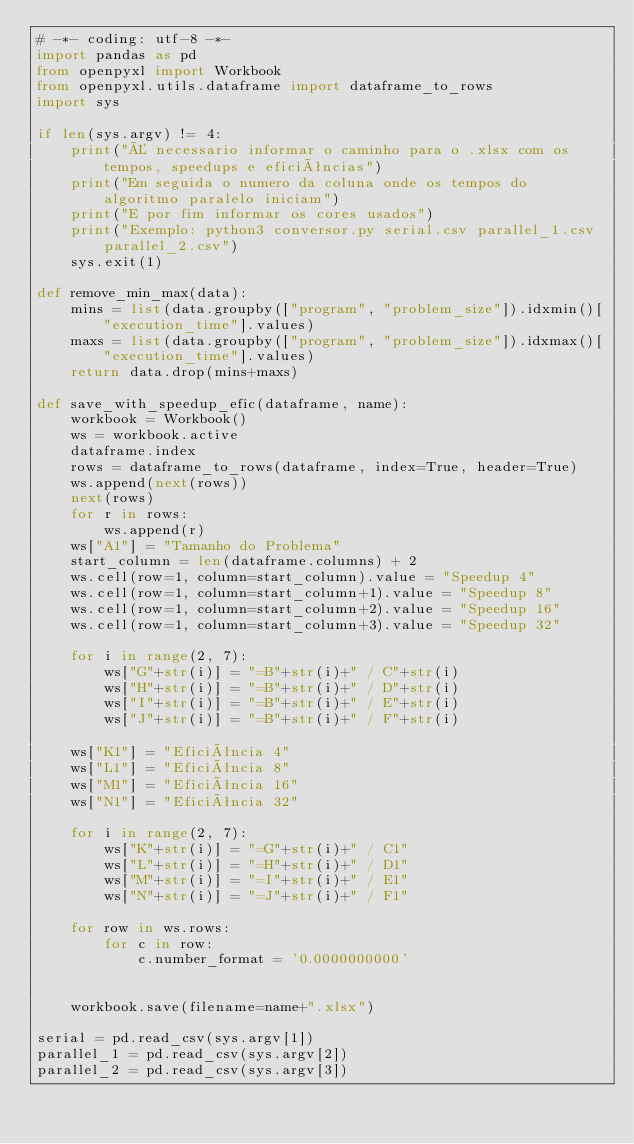Convert code to text. <code><loc_0><loc_0><loc_500><loc_500><_Python_># -*- coding: utf-8 -*-
import pandas as pd
from openpyxl import Workbook
from openpyxl.utils.dataframe import dataframe_to_rows
import sys

if len(sys.argv) != 4:
    print("É necessario informar o caminho para o .xlsx com os tempos, speedups e eficiências")
    print("Em seguida o numero da coluna onde os tempos do algoritmo paralelo iniciam")
    print("E por fim informar os cores usados")
    print("Exemplo: python3 conversor.py serial.csv parallel_1.csv parallel_2.csv")
    sys.exit(1)

def remove_min_max(data):
    mins = list(data.groupby(["program", "problem_size"]).idxmin()["execution_time"].values)
    maxs = list(data.groupby(["program", "problem_size"]).idxmax()["execution_time"].values)
    return data.drop(mins+maxs)

def save_with_speedup_efic(dataframe, name):
    workbook = Workbook()
    ws = workbook.active
    dataframe.index
    rows = dataframe_to_rows(dataframe, index=True, header=True)
    ws.append(next(rows))
    next(rows)
    for r in rows:
        ws.append(r)
    ws["A1"] = "Tamanho do Problema"
    start_column = len(dataframe.columns) + 2
    ws.cell(row=1, column=start_column).value = "Speedup 4"
    ws.cell(row=1, column=start_column+1).value = "Speedup 8"
    ws.cell(row=1, column=start_column+2).value = "Speedup 16"
    ws.cell(row=1, column=start_column+3).value = "Speedup 32"

    for i in range(2, 7):
        ws["G"+str(i)] = "=B"+str(i)+" / C"+str(i)
        ws["H"+str(i)] = "=B"+str(i)+" / D"+str(i)
        ws["I"+str(i)] = "=B"+str(i)+" / E"+str(i)
        ws["J"+str(i)] = "=B"+str(i)+" / F"+str(i)

    ws["K1"] = "Eficiência 4"
    ws["L1"] = "Eficiência 8"
    ws["M1"] = "Eficiência 16"
    ws["N1"] = "Eficiência 32"

    for i in range(2, 7):
        ws["K"+str(i)] = "=G"+str(i)+" / C1"
        ws["L"+str(i)] = "=H"+str(i)+" / D1"
        ws["M"+str(i)] = "=I"+str(i)+" / E1"
        ws["N"+str(i)] = "=J"+str(i)+" / F1"

    for row in ws.rows:
        for c in row:
            c.number_format = '0.0000000000'


    workbook.save(filename=name+".xlsx")

serial = pd.read_csv(sys.argv[1])
parallel_1 = pd.read_csv(sys.argv[2])
parallel_2 = pd.read_csv(sys.argv[3])</code> 